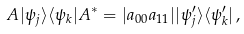<formula> <loc_0><loc_0><loc_500><loc_500>A | \psi _ { j } \rangle \langle \psi _ { k } | A ^ { * } = | a _ { 0 0 } a _ { 1 1 } | | \psi _ { j } ^ { \prime } \rangle \langle \psi _ { k } ^ { \prime } | \, ,</formula> 